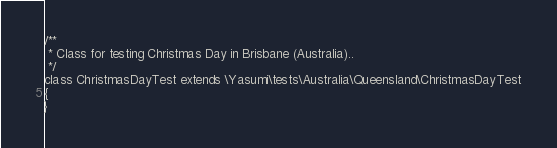<code> <loc_0><loc_0><loc_500><loc_500><_PHP_>
/**
 * Class for testing Christmas Day in Brisbane (Australia)..
 */
class ChristmasDayTest extends \Yasumi\tests\Australia\Queensland\ChristmasDayTest
{
}
</code> 